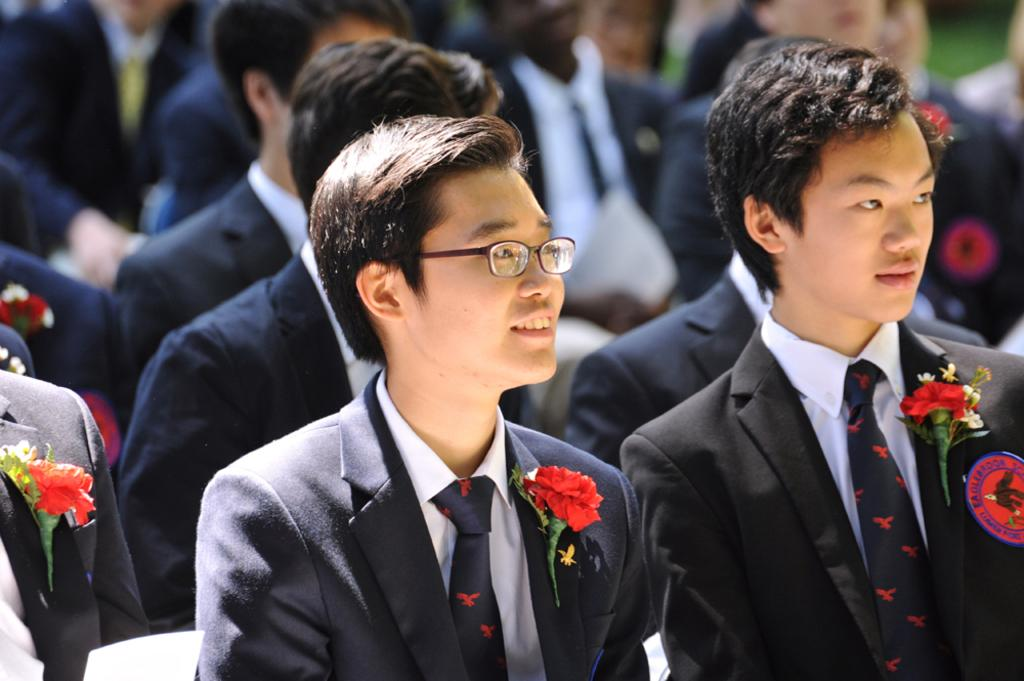What is the main subject of the image? The main subject of the image is a group of persons. What are the persons doing in the image? The persons are sitting on chairs in the image. Are there any additional details about the persons' attire? Yes, some of the persons have flowers on their blazers. Where are the flowers located in the image? The flowers are visible at the bottom of the image. What type of creature can be seen using a brush in the image? There is no creature or brush present in the image. Can you describe the burst of colors in the image? There is no burst of colors mentioned in the provided facts; the image primarily features a group of persons sitting on chairs. 